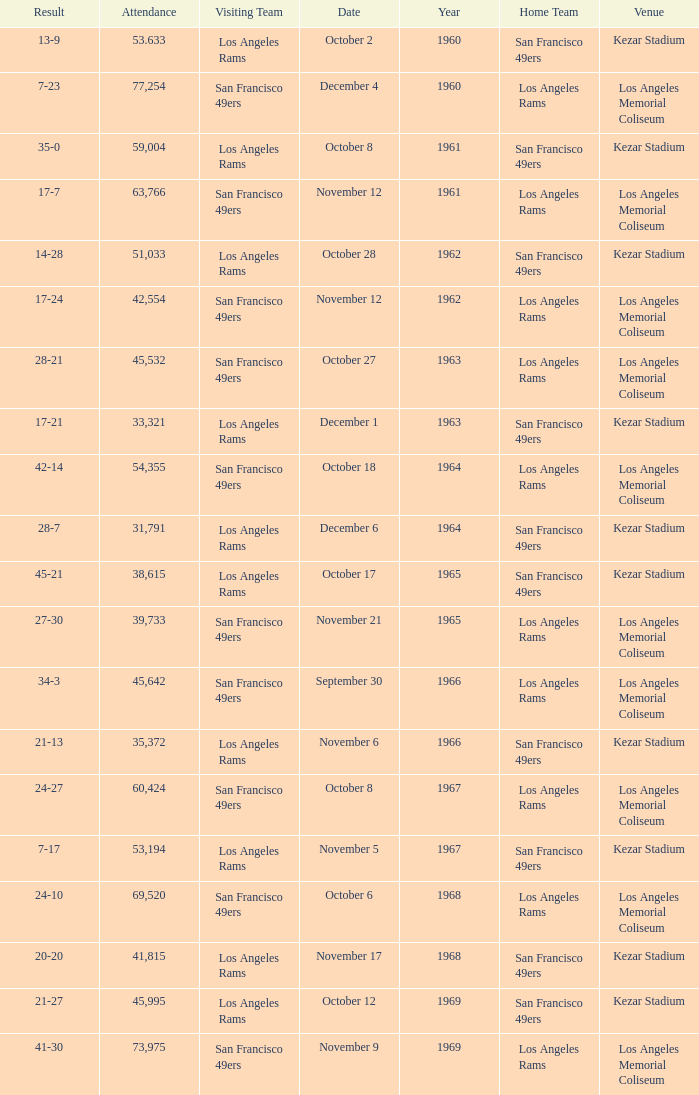What was the total attendance for a result of 7-23 before 1960? None. 